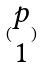<formula> <loc_0><loc_0><loc_500><loc_500>( \begin{matrix} p \\ 1 \end{matrix} )</formula> 